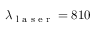Convert formula to latex. <formula><loc_0><loc_0><loc_500><loc_500>\lambda _ { l a s e r } = 8 1 0</formula> 